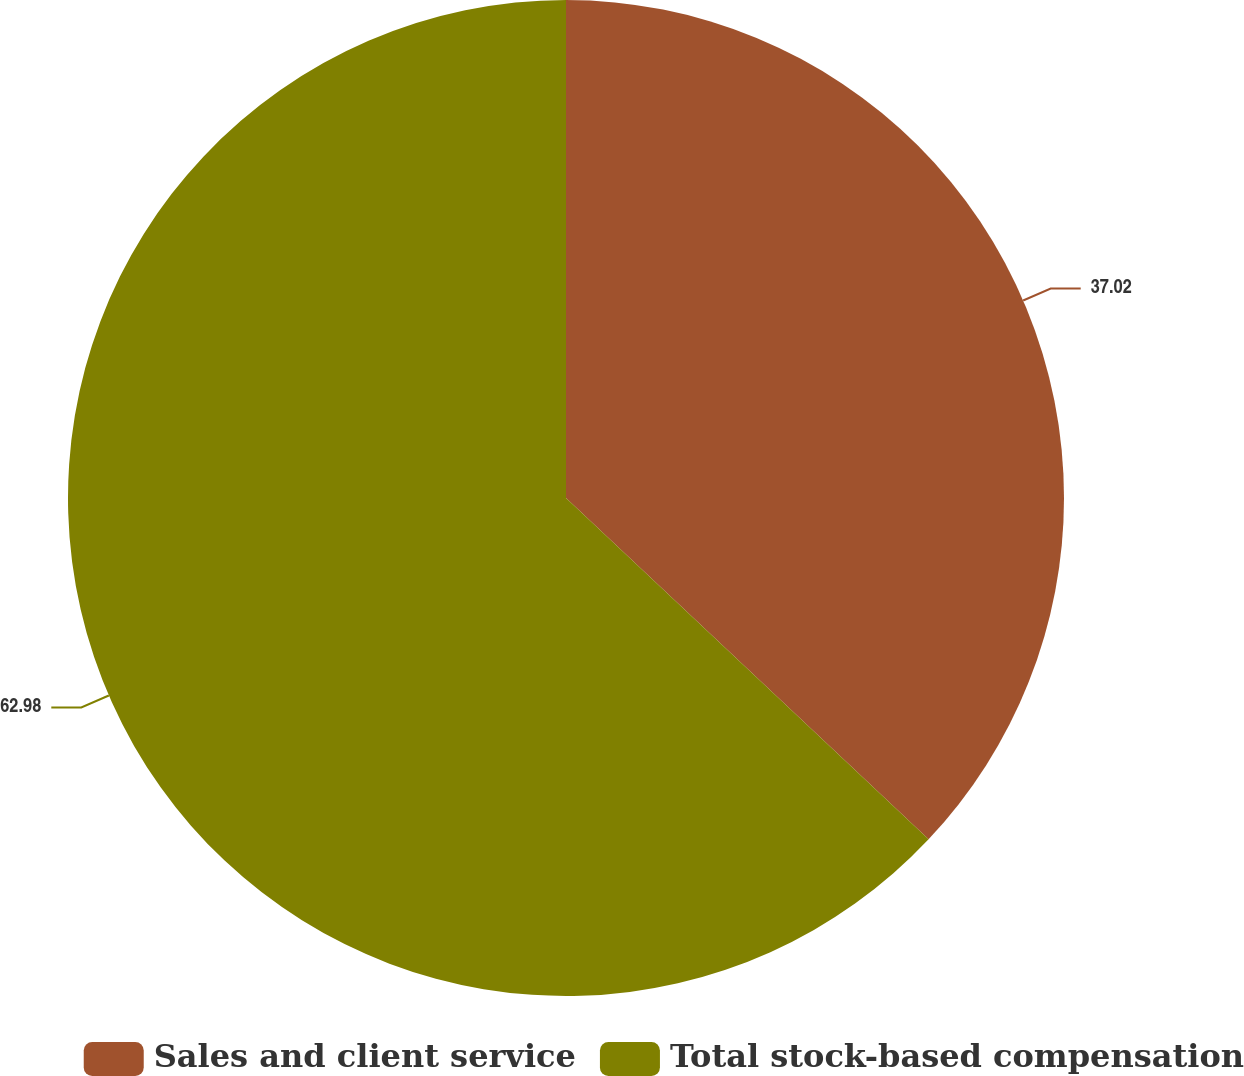<chart> <loc_0><loc_0><loc_500><loc_500><pie_chart><fcel>Sales and client service<fcel>Total stock-based compensation<nl><fcel>37.02%<fcel>62.98%<nl></chart> 